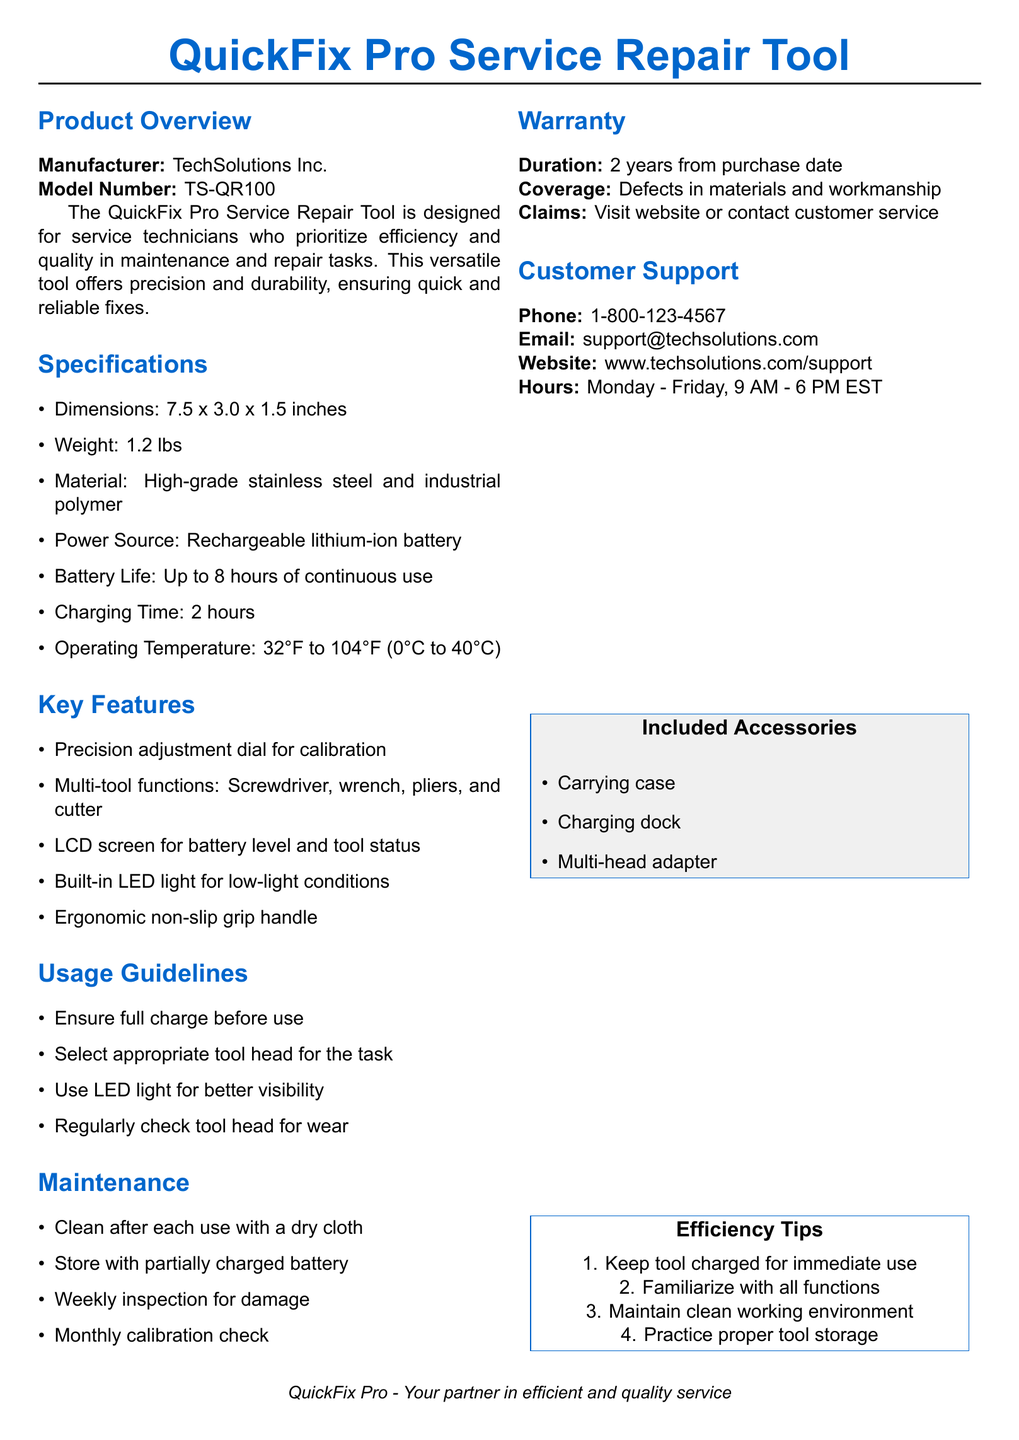What is the manufacturer of the tool? The manufacturer is specified in the product overview section of the document.
Answer: TechSolutions Inc What is the model number? The model number is listed directly under the manufacturer in the product overview.
Answer: TS-QR100 What is the weight of the QuickFix Pro? The weight is mentioned in the specifications section of the document.
Answer: 1.2 lbs What is the battery life? The battery life is indicated in the specifications section detailing how long the tool can be used continuously.
Answer: Up to 8 hours What maintenance is recommended after each use? The maintenance section suggests cleaning after use, which is noted explicitly.
Answer: Clean after each use How many included accessories are listed? The included accessories are detailed at the bottom, and you can count them as specified in the list.
Answer: Three What is the warranty duration? The warranty information is found under the warranty section of the document, specifically the duration of coverage.
Answer: 2 years What should be done weekly for maintenance? The maintenance section outlines actions to be taken regularly, indicating what should be inspected every week.
Answer: Weekly inspection for damage Which feature aids visibility in low light? The key features section highlights tools and features, indicating which one helps in low visibility scenarios.
Answer: Built-in LED light What is one efficiency tip provided? The efficiency tips are mentioned at the end of the document, listing practical advice for usage.
Answer: Keep tool charged for immediate use 